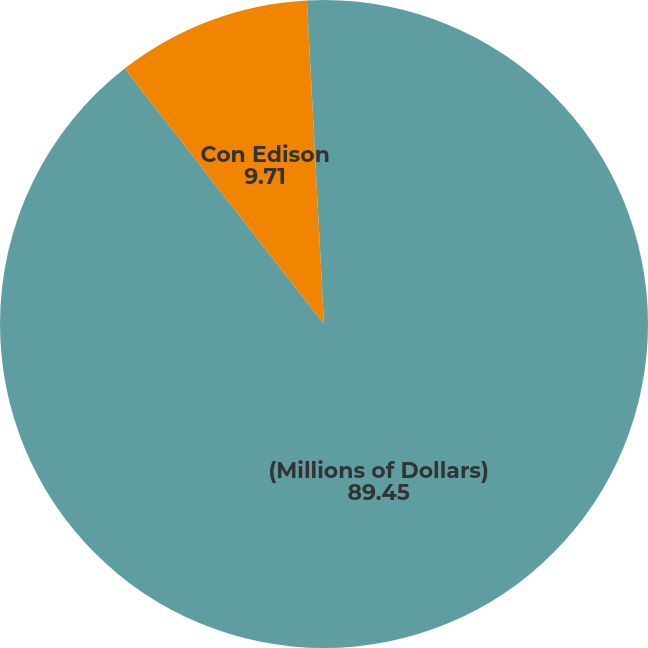Convert chart. <chart><loc_0><loc_0><loc_500><loc_500><pie_chart><fcel>(Millions of Dollars)<fcel>Con Edison<fcel>CECONY<nl><fcel>89.45%<fcel>9.71%<fcel>0.84%<nl></chart> 